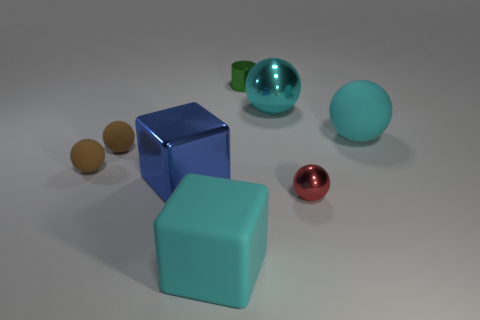Add 1 gray shiny objects. How many objects exist? 9 Subtract all tiny shiny spheres. How many spheres are left? 4 Subtract all purple cubes. How many brown balls are left? 2 Subtract all brown spheres. How many spheres are left? 3 Subtract 0 red cylinders. How many objects are left? 8 Subtract all cubes. How many objects are left? 6 Subtract 1 cylinders. How many cylinders are left? 0 Subtract all gray cubes. Subtract all red cylinders. How many cubes are left? 2 Subtract all small green matte balls. Subtract all small brown matte spheres. How many objects are left? 6 Add 3 large shiny things. How many large shiny things are left? 5 